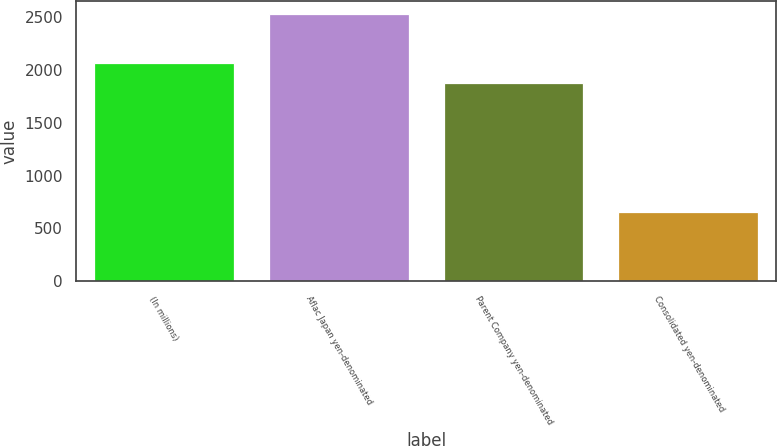<chart> <loc_0><loc_0><loc_500><loc_500><bar_chart><fcel>(In millions)<fcel>Aflac Japan yen-denominated<fcel>Parent Company yen-denominated<fcel>Consolidated yen-denominated<nl><fcel>2063.6<fcel>2528<fcel>1876<fcel>652<nl></chart> 